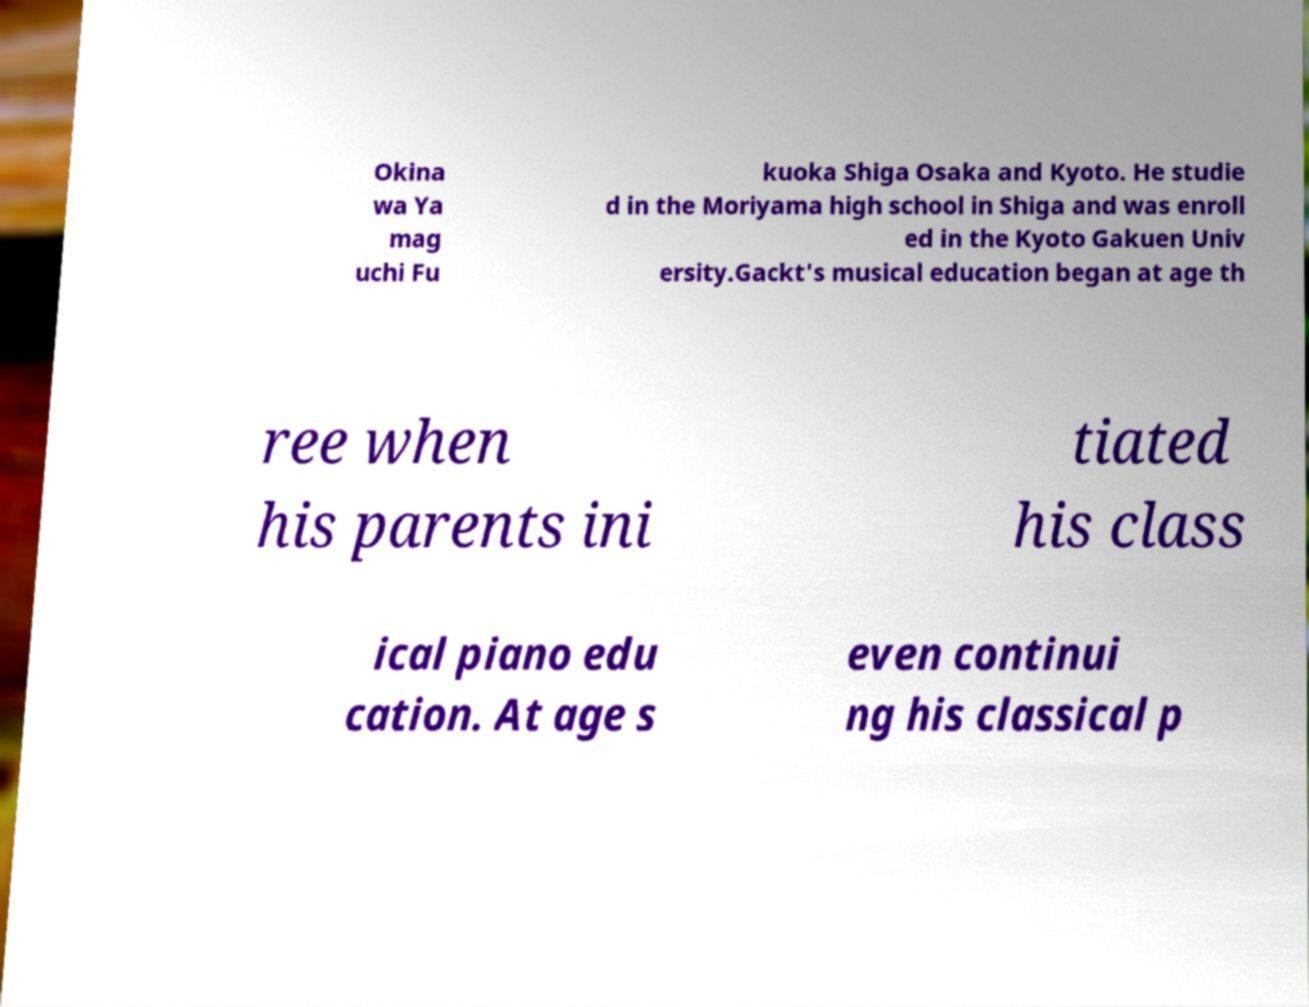There's text embedded in this image that I need extracted. Can you transcribe it verbatim? Okina wa Ya mag uchi Fu kuoka Shiga Osaka and Kyoto. He studie d in the Moriyama high school in Shiga and was enroll ed in the Kyoto Gakuen Univ ersity.Gackt's musical education began at age th ree when his parents ini tiated his class ical piano edu cation. At age s even continui ng his classical p 